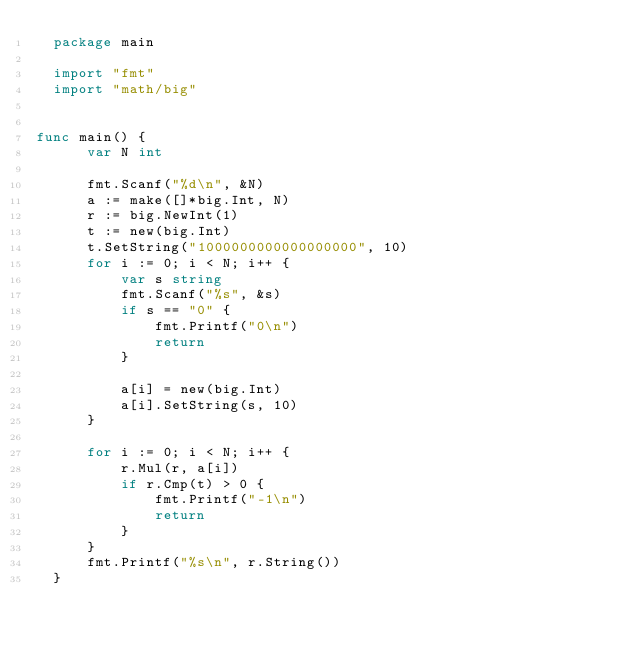<code> <loc_0><loc_0><loc_500><loc_500><_Go_>  package main                                                                                                                                                                                                
                                                                                                                                                                                                              
  import "fmt"                                                                                                                                                                                                
  import "math/big"                                                                                                                                                                                           
                                                                                                                                                                                                              
                                                                                                                                                                                                              
func main() {                                                                                                                                                                                               
      var N int                                                                                                                                                                                               
                                                                                                                                                                                                              
      fmt.Scanf("%d\n", &N)                                                                                                                                                                                   
      a := make([]*big.Int, N)                                                                                                                                                                                
      r := big.NewInt(1)                                                                                                                                                                                      
      t := new(big.Int)                                                                                                                                                                                       
      t.SetString("1000000000000000000", 10)                                                                                                                                                                  
      for i := 0; i < N; i++ {                                                                                                                                                                                
          var s string                                                                                                                                                                                        
          fmt.Scanf("%s", &s)                                                                                                                                                                                 
          if s == "0" {                                                                                                                                                                                       
              fmt.Printf("0\n")                                                                                                                                                                               
              return                                                                                                                                                                                          
          }                                                                                                                                                                                                   
                                                                                                                                                                                                              
          a[i] = new(big.Int)                                                                                                                                                                                 
          a[i].SetString(s, 10)                                                                                                                                                                               
      }                                                                                                                                                                                                       
                                                                                                                                                                                                              
      for i := 0; i < N; i++ {                                                                                                                                                                                
          r.Mul(r, a[i])                                                                                                                                                                                      
          if r.Cmp(t) > 0 {                                                                                                                                                                                   
              fmt.Printf("-1\n")                                                                                                                                                                              
              return                                                                                                                                                                                          
          }                                                                                                                                                                                                   
      }                                                                                                                                                                                                       
      fmt.Printf("%s\n", r.String())                                                                                                                                                                          
  }  </code> 